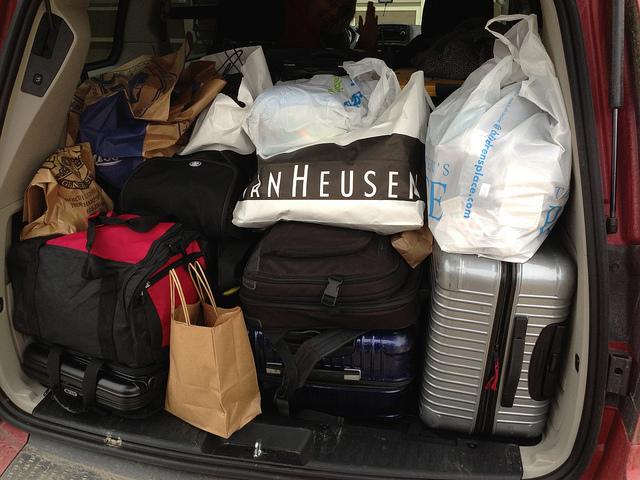Is the read door of the vehicle open?
Answer briefly. Yes. By looking at the luggage, how many people do you think are traveling in the vehicle?
Keep it brief. 3. What is the person in the driver's seat doing?
Be succinct. Driving. 